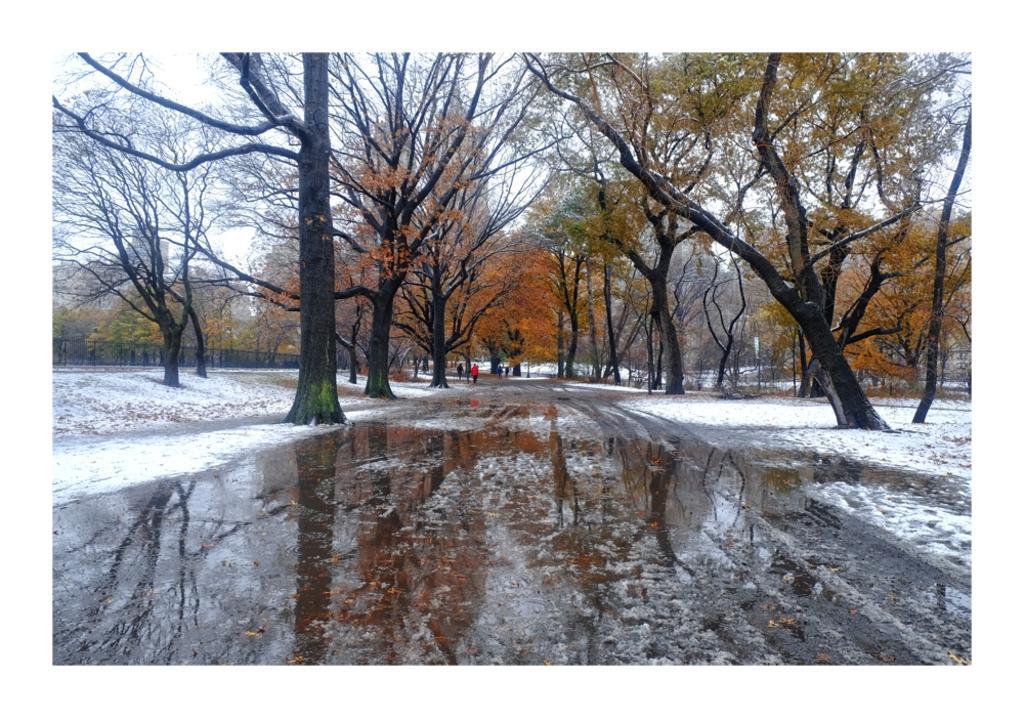In one or two sentences, can you explain what this image depicts? In the foreground of this image, there is water on the road. On either side, there are trees and the snow. In the background, there is sky and few people. On the left, there is a fencing and it seems like a building in the background. 